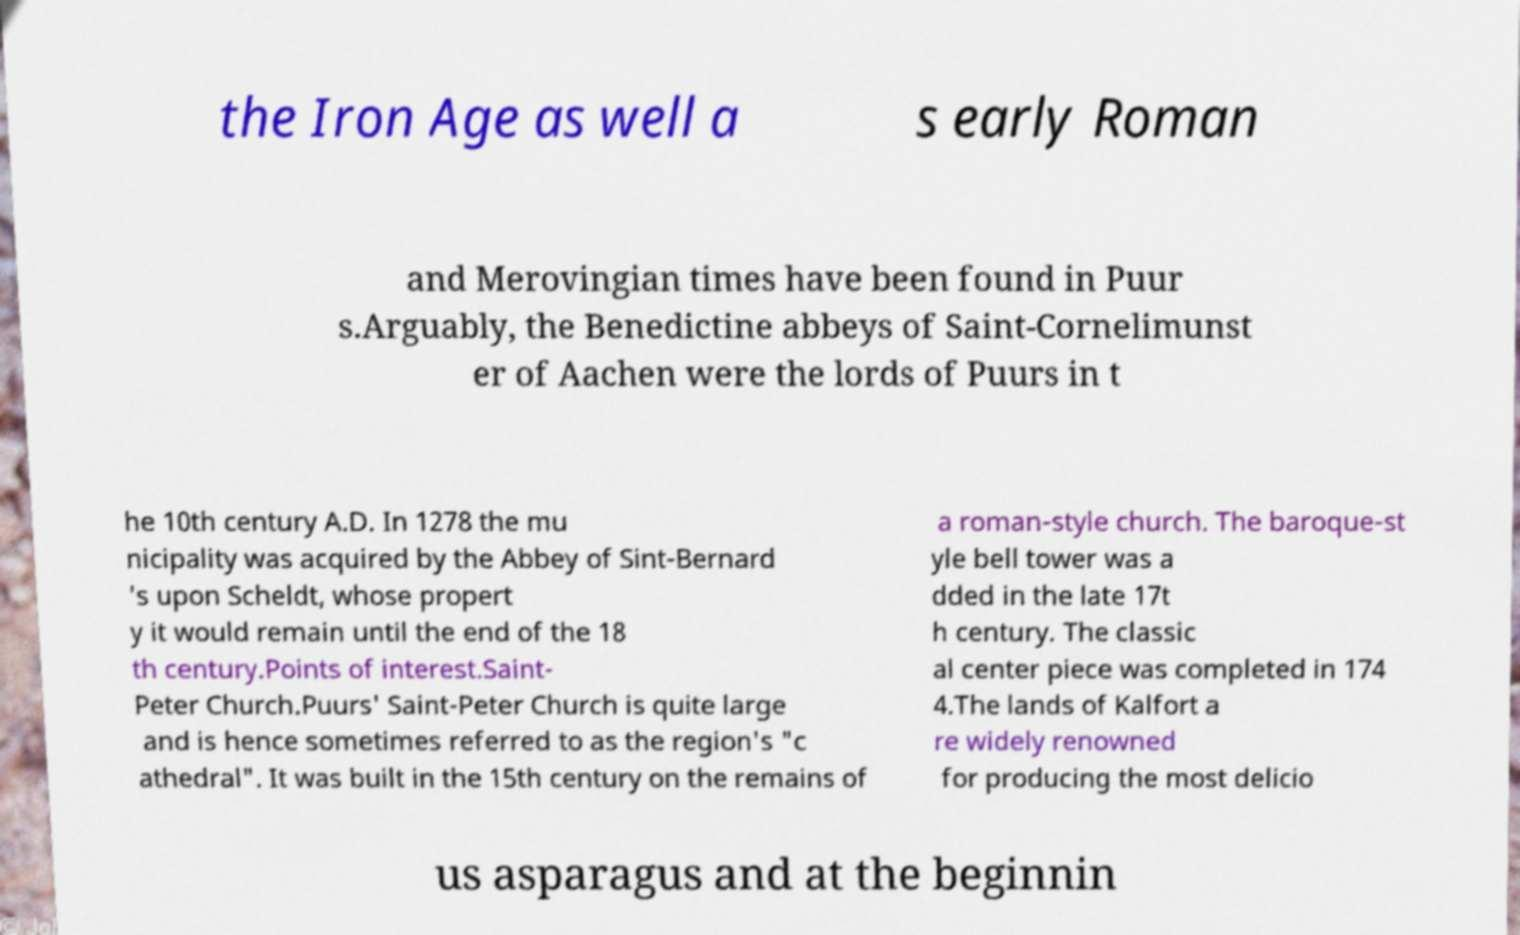Can you accurately transcribe the text from the provided image for me? the Iron Age as well a s early Roman and Merovingian times have been found in Puur s.Arguably, the Benedictine abbeys of Saint-Cornelimunst er of Aachen were the lords of Puurs in t he 10th century A.D. In 1278 the mu nicipality was acquired by the Abbey of Sint-Bernard 's upon Scheldt, whose propert y it would remain until the end of the 18 th century.Points of interest.Saint- Peter Church.Puurs' Saint-Peter Church is quite large and is hence sometimes referred to as the region's "c athedral". It was built in the 15th century on the remains of a roman-style church. The baroque-st yle bell tower was a dded in the late 17t h century. The classic al center piece was completed in 174 4.The lands of Kalfort a re widely renowned for producing the most delicio us asparagus and at the beginnin 